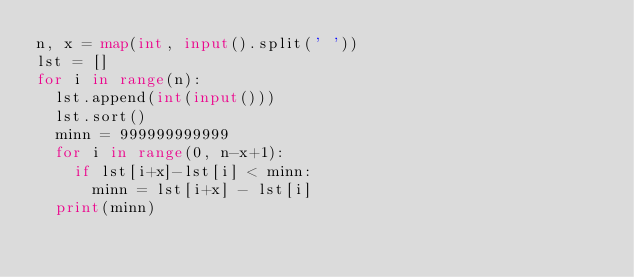<code> <loc_0><loc_0><loc_500><loc_500><_Python_>n, x = map(int, input().split(' '))
lst = []
for i in range(n):
  lst.append(int(input()))
  lst.sort()
  minn = 999999999999
  for i in range(0, n-x+1):
    if lst[i+x]-lst[i] < minn:
      minn = lst[i+x] - lst[i]
  print(minn)</code> 